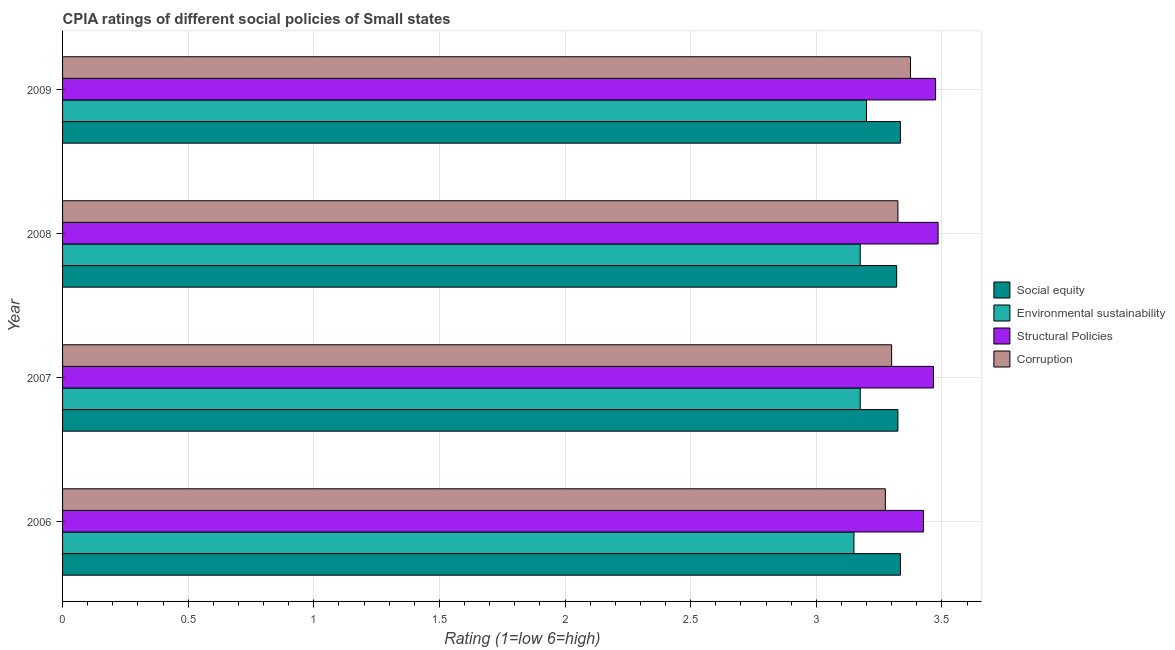How many different coloured bars are there?
Your answer should be compact. 4. How many groups of bars are there?
Offer a very short reply. 4. Are the number of bars on each tick of the Y-axis equal?
Your answer should be compact. Yes. What is the cpia rating of social equity in 2008?
Your response must be concise. 3.32. Across all years, what is the maximum cpia rating of social equity?
Offer a very short reply. 3.33. Across all years, what is the minimum cpia rating of environmental sustainability?
Provide a short and direct response. 3.15. What is the total cpia rating of structural policies in the graph?
Provide a short and direct response. 13.85. What is the difference between the cpia rating of structural policies in 2007 and that in 2008?
Ensure brevity in your answer.  -0.02. What is the difference between the cpia rating of social equity in 2007 and the cpia rating of corruption in 2008?
Your answer should be compact. 0. What is the average cpia rating of corruption per year?
Provide a short and direct response. 3.32. In the year 2006, what is the difference between the cpia rating of corruption and cpia rating of social equity?
Your answer should be very brief. -0.06. Is the cpia rating of environmental sustainability in 2007 less than that in 2008?
Make the answer very short. No. Is the difference between the cpia rating of structural policies in 2007 and 2009 greater than the difference between the cpia rating of corruption in 2007 and 2009?
Offer a terse response. Yes. What is the difference between the highest and the second highest cpia rating of environmental sustainability?
Keep it short and to the point. 0.03. In how many years, is the cpia rating of environmental sustainability greater than the average cpia rating of environmental sustainability taken over all years?
Your response must be concise. 1. Is the sum of the cpia rating of structural policies in 2006 and 2008 greater than the maximum cpia rating of corruption across all years?
Your answer should be compact. Yes. What does the 3rd bar from the top in 2006 represents?
Give a very brief answer. Environmental sustainability. What does the 1st bar from the bottom in 2009 represents?
Give a very brief answer. Social equity. Is it the case that in every year, the sum of the cpia rating of social equity and cpia rating of environmental sustainability is greater than the cpia rating of structural policies?
Your response must be concise. Yes. How many bars are there?
Make the answer very short. 16. What is the difference between two consecutive major ticks on the X-axis?
Provide a short and direct response. 0.5. Are the values on the major ticks of X-axis written in scientific E-notation?
Make the answer very short. No. Does the graph contain grids?
Offer a very short reply. Yes. How many legend labels are there?
Give a very brief answer. 4. How are the legend labels stacked?
Offer a very short reply. Vertical. What is the title of the graph?
Offer a terse response. CPIA ratings of different social policies of Small states. Does "Iceland" appear as one of the legend labels in the graph?
Your answer should be very brief. No. What is the label or title of the X-axis?
Give a very brief answer. Rating (1=low 6=high). What is the Rating (1=low 6=high) in Social equity in 2006?
Make the answer very short. 3.33. What is the Rating (1=low 6=high) in Environmental sustainability in 2006?
Offer a very short reply. 3.15. What is the Rating (1=low 6=high) in Structural Policies in 2006?
Provide a short and direct response. 3.43. What is the Rating (1=low 6=high) of Corruption in 2006?
Your answer should be compact. 3.27. What is the Rating (1=low 6=high) of Social equity in 2007?
Your answer should be very brief. 3.33. What is the Rating (1=low 6=high) in Environmental sustainability in 2007?
Make the answer very short. 3.17. What is the Rating (1=low 6=high) of Structural Policies in 2007?
Your answer should be compact. 3.47. What is the Rating (1=low 6=high) in Corruption in 2007?
Provide a succinct answer. 3.3. What is the Rating (1=low 6=high) of Social equity in 2008?
Your answer should be compact. 3.32. What is the Rating (1=low 6=high) of Environmental sustainability in 2008?
Your answer should be compact. 3.17. What is the Rating (1=low 6=high) of Structural Policies in 2008?
Your answer should be compact. 3.48. What is the Rating (1=low 6=high) in Corruption in 2008?
Your response must be concise. 3.33. What is the Rating (1=low 6=high) of Social equity in 2009?
Ensure brevity in your answer.  3.33. What is the Rating (1=low 6=high) in Environmental sustainability in 2009?
Ensure brevity in your answer.  3.2. What is the Rating (1=low 6=high) in Structural Policies in 2009?
Provide a succinct answer. 3.48. What is the Rating (1=low 6=high) of Corruption in 2009?
Keep it short and to the point. 3.38. Across all years, what is the maximum Rating (1=low 6=high) in Social equity?
Provide a succinct answer. 3.33. Across all years, what is the maximum Rating (1=low 6=high) in Structural Policies?
Your answer should be very brief. 3.48. Across all years, what is the maximum Rating (1=low 6=high) of Corruption?
Give a very brief answer. 3.38. Across all years, what is the minimum Rating (1=low 6=high) in Social equity?
Your answer should be very brief. 3.32. Across all years, what is the minimum Rating (1=low 6=high) in Environmental sustainability?
Offer a terse response. 3.15. Across all years, what is the minimum Rating (1=low 6=high) of Structural Policies?
Give a very brief answer. 3.43. Across all years, what is the minimum Rating (1=low 6=high) of Corruption?
Keep it short and to the point. 3.27. What is the total Rating (1=low 6=high) in Social equity in the graph?
Offer a very short reply. 13.31. What is the total Rating (1=low 6=high) in Structural Policies in the graph?
Your response must be concise. 13.85. What is the total Rating (1=low 6=high) of Corruption in the graph?
Offer a very short reply. 13.28. What is the difference between the Rating (1=low 6=high) in Social equity in 2006 and that in 2007?
Provide a short and direct response. 0.01. What is the difference between the Rating (1=low 6=high) in Environmental sustainability in 2006 and that in 2007?
Your response must be concise. -0.03. What is the difference between the Rating (1=low 6=high) of Structural Policies in 2006 and that in 2007?
Your response must be concise. -0.04. What is the difference between the Rating (1=low 6=high) of Corruption in 2006 and that in 2007?
Offer a very short reply. -0.03. What is the difference between the Rating (1=low 6=high) in Social equity in 2006 and that in 2008?
Your response must be concise. 0.01. What is the difference between the Rating (1=low 6=high) in Environmental sustainability in 2006 and that in 2008?
Make the answer very short. -0.03. What is the difference between the Rating (1=low 6=high) in Structural Policies in 2006 and that in 2008?
Provide a short and direct response. -0.06. What is the difference between the Rating (1=low 6=high) in Corruption in 2006 and that in 2008?
Ensure brevity in your answer.  -0.05. What is the difference between the Rating (1=low 6=high) in Environmental sustainability in 2006 and that in 2009?
Ensure brevity in your answer.  -0.05. What is the difference between the Rating (1=low 6=high) in Structural Policies in 2006 and that in 2009?
Your answer should be compact. -0.05. What is the difference between the Rating (1=low 6=high) of Corruption in 2006 and that in 2009?
Your response must be concise. -0.1. What is the difference between the Rating (1=low 6=high) in Social equity in 2007 and that in 2008?
Offer a terse response. 0.01. What is the difference between the Rating (1=low 6=high) in Environmental sustainability in 2007 and that in 2008?
Make the answer very short. 0. What is the difference between the Rating (1=low 6=high) in Structural Policies in 2007 and that in 2008?
Provide a succinct answer. -0.02. What is the difference between the Rating (1=low 6=high) of Corruption in 2007 and that in 2008?
Provide a short and direct response. -0.03. What is the difference between the Rating (1=low 6=high) in Social equity in 2007 and that in 2009?
Make the answer very short. -0.01. What is the difference between the Rating (1=low 6=high) of Environmental sustainability in 2007 and that in 2009?
Offer a very short reply. -0.03. What is the difference between the Rating (1=low 6=high) in Structural Policies in 2007 and that in 2009?
Your response must be concise. -0.01. What is the difference between the Rating (1=low 6=high) in Corruption in 2007 and that in 2009?
Make the answer very short. -0.07. What is the difference between the Rating (1=low 6=high) in Social equity in 2008 and that in 2009?
Give a very brief answer. -0.01. What is the difference between the Rating (1=low 6=high) of Environmental sustainability in 2008 and that in 2009?
Your answer should be compact. -0.03. What is the difference between the Rating (1=low 6=high) of Structural Policies in 2008 and that in 2009?
Ensure brevity in your answer.  0.01. What is the difference between the Rating (1=low 6=high) of Corruption in 2008 and that in 2009?
Your answer should be compact. -0.05. What is the difference between the Rating (1=low 6=high) of Social equity in 2006 and the Rating (1=low 6=high) of Environmental sustainability in 2007?
Provide a succinct answer. 0.16. What is the difference between the Rating (1=low 6=high) in Social equity in 2006 and the Rating (1=low 6=high) in Structural Policies in 2007?
Your answer should be very brief. -0.13. What is the difference between the Rating (1=low 6=high) of Social equity in 2006 and the Rating (1=low 6=high) of Corruption in 2007?
Make the answer very short. 0.04. What is the difference between the Rating (1=low 6=high) in Environmental sustainability in 2006 and the Rating (1=low 6=high) in Structural Policies in 2007?
Offer a terse response. -0.32. What is the difference between the Rating (1=low 6=high) of Structural Policies in 2006 and the Rating (1=low 6=high) of Corruption in 2007?
Provide a short and direct response. 0.13. What is the difference between the Rating (1=low 6=high) in Social equity in 2006 and the Rating (1=low 6=high) in Environmental sustainability in 2008?
Give a very brief answer. 0.16. What is the difference between the Rating (1=low 6=high) in Environmental sustainability in 2006 and the Rating (1=low 6=high) in Structural Policies in 2008?
Your response must be concise. -0.34. What is the difference between the Rating (1=low 6=high) of Environmental sustainability in 2006 and the Rating (1=low 6=high) of Corruption in 2008?
Your answer should be very brief. -0.17. What is the difference between the Rating (1=low 6=high) of Structural Policies in 2006 and the Rating (1=low 6=high) of Corruption in 2008?
Your response must be concise. 0.1. What is the difference between the Rating (1=low 6=high) of Social equity in 2006 and the Rating (1=low 6=high) of Environmental sustainability in 2009?
Your response must be concise. 0.14. What is the difference between the Rating (1=low 6=high) in Social equity in 2006 and the Rating (1=low 6=high) in Structural Policies in 2009?
Make the answer very short. -0.14. What is the difference between the Rating (1=low 6=high) in Social equity in 2006 and the Rating (1=low 6=high) in Corruption in 2009?
Your answer should be very brief. -0.04. What is the difference between the Rating (1=low 6=high) in Environmental sustainability in 2006 and the Rating (1=low 6=high) in Structural Policies in 2009?
Make the answer very short. -0.33. What is the difference between the Rating (1=low 6=high) of Environmental sustainability in 2006 and the Rating (1=low 6=high) of Corruption in 2009?
Your answer should be compact. -0.23. What is the difference between the Rating (1=low 6=high) in Structural Policies in 2006 and the Rating (1=low 6=high) in Corruption in 2009?
Your answer should be compact. 0.05. What is the difference between the Rating (1=low 6=high) in Social equity in 2007 and the Rating (1=low 6=high) in Environmental sustainability in 2008?
Offer a very short reply. 0.15. What is the difference between the Rating (1=low 6=high) in Social equity in 2007 and the Rating (1=low 6=high) in Structural Policies in 2008?
Your response must be concise. -0.16. What is the difference between the Rating (1=low 6=high) in Social equity in 2007 and the Rating (1=low 6=high) in Corruption in 2008?
Your answer should be very brief. 0. What is the difference between the Rating (1=low 6=high) in Environmental sustainability in 2007 and the Rating (1=low 6=high) in Structural Policies in 2008?
Ensure brevity in your answer.  -0.31. What is the difference between the Rating (1=low 6=high) in Structural Policies in 2007 and the Rating (1=low 6=high) in Corruption in 2008?
Offer a terse response. 0.14. What is the difference between the Rating (1=low 6=high) of Social equity in 2007 and the Rating (1=low 6=high) of Environmental sustainability in 2009?
Your answer should be very brief. 0.12. What is the difference between the Rating (1=low 6=high) of Social equity in 2007 and the Rating (1=low 6=high) of Structural Policies in 2009?
Provide a short and direct response. -0.15. What is the difference between the Rating (1=low 6=high) of Environmental sustainability in 2007 and the Rating (1=low 6=high) of Structural Policies in 2009?
Your response must be concise. -0.3. What is the difference between the Rating (1=low 6=high) of Structural Policies in 2007 and the Rating (1=low 6=high) of Corruption in 2009?
Give a very brief answer. 0.09. What is the difference between the Rating (1=low 6=high) of Social equity in 2008 and the Rating (1=low 6=high) of Environmental sustainability in 2009?
Your answer should be very brief. 0.12. What is the difference between the Rating (1=low 6=high) of Social equity in 2008 and the Rating (1=low 6=high) of Structural Policies in 2009?
Offer a terse response. -0.15. What is the difference between the Rating (1=low 6=high) in Social equity in 2008 and the Rating (1=low 6=high) in Corruption in 2009?
Offer a terse response. -0.06. What is the difference between the Rating (1=low 6=high) of Environmental sustainability in 2008 and the Rating (1=low 6=high) of Structural Policies in 2009?
Provide a short and direct response. -0.3. What is the difference between the Rating (1=low 6=high) in Environmental sustainability in 2008 and the Rating (1=low 6=high) in Corruption in 2009?
Keep it short and to the point. -0.2. What is the difference between the Rating (1=low 6=high) of Structural Policies in 2008 and the Rating (1=low 6=high) of Corruption in 2009?
Your answer should be very brief. 0.11. What is the average Rating (1=low 6=high) in Social equity per year?
Give a very brief answer. 3.33. What is the average Rating (1=low 6=high) in Environmental sustainability per year?
Offer a terse response. 3.17. What is the average Rating (1=low 6=high) in Structural Policies per year?
Make the answer very short. 3.46. What is the average Rating (1=low 6=high) of Corruption per year?
Provide a succinct answer. 3.32. In the year 2006, what is the difference between the Rating (1=low 6=high) of Social equity and Rating (1=low 6=high) of Environmental sustainability?
Ensure brevity in your answer.  0.18. In the year 2006, what is the difference between the Rating (1=low 6=high) in Social equity and Rating (1=low 6=high) in Structural Policies?
Your response must be concise. -0.09. In the year 2006, what is the difference between the Rating (1=low 6=high) of Environmental sustainability and Rating (1=low 6=high) of Structural Policies?
Your response must be concise. -0.28. In the year 2006, what is the difference between the Rating (1=low 6=high) of Environmental sustainability and Rating (1=low 6=high) of Corruption?
Your answer should be very brief. -0.12. In the year 2006, what is the difference between the Rating (1=low 6=high) of Structural Policies and Rating (1=low 6=high) of Corruption?
Your answer should be compact. 0.15. In the year 2007, what is the difference between the Rating (1=low 6=high) of Social equity and Rating (1=low 6=high) of Environmental sustainability?
Your response must be concise. 0.15. In the year 2007, what is the difference between the Rating (1=low 6=high) in Social equity and Rating (1=low 6=high) in Structural Policies?
Provide a succinct answer. -0.14. In the year 2007, what is the difference between the Rating (1=low 6=high) in Social equity and Rating (1=low 6=high) in Corruption?
Provide a succinct answer. 0.03. In the year 2007, what is the difference between the Rating (1=low 6=high) of Environmental sustainability and Rating (1=low 6=high) of Structural Policies?
Your response must be concise. -0.29. In the year 2007, what is the difference between the Rating (1=low 6=high) in Environmental sustainability and Rating (1=low 6=high) in Corruption?
Keep it short and to the point. -0.12. In the year 2007, what is the difference between the Rating (1=low 6=high) in Structural Policies and Rating (1=low 6=high) in Corruption?
Offer a terse response. 0.17. In the year 2008, what is the difference between the Rating (1=low 6=high) in Social equity and Rating (1=low 6=high) in Environmental sustainability?
Provide a short and direct response. 0.14. In the year 2008, what is the difference between the Rating (1=low 6=high) of Social equity and Rating (1=low 6=high) of Structural Policies?
Make the answer very short. -0.17. In the year 2008, what is the difference between the Rating (1=low 6=high) of Social equity and Rating (1=low 6=high) of Corruption?
Your answer should be compact. -0.01. In the year 2008, what is the difference between the Rating (1=low 6=high) of Environmental sustainability and Rating (1=low 6=high) of Structural Policies?
Provide a succinct answer. -0.31. In the year 2008, what is the difference between the Rating (1=low 6=high) in Structural Policies and Rating (1=low 6=high) in Corruption?
Give a very brief answer. 0.16. In the year 2009, what is the difference between the Rating (1=low 6=high) in Social equity and Rating (1=low 6=high) in Environmental sustainability?
Ensure brevity in your answer.  0.14. In the year 2009, what is the difference between the Rating (1=low 6=high) in Social equity and Rating (1=low 6=high) in Structural Policies?
Offer a very short reply. -0.14. In the year 2009, what is the difference between the Rating (1=low 6=high) of Social equity and Rating (1=low 6=high) of Corruption?
Ensure brevity in your answer.  -0.04. In the year 2009, what is the difference between the Rating (1=low 6=high) of Environmental sustainability and Rating (1=low 6=high) of Structural Policies?
Provide a succinct answer. -0.28. In the year 2009, what is the difference between the Rating (1=low 6=high) of Environmental sustainability and Rating (1=low 6=high) of Corruption?
Your response must be concise. -0.17. In the year 2009, what is the difference between the Rating (1=low 6=high) in Structural Policies and Rating (1=low 6=high) in Corruption?
Give a very brief answer. 0.1. What is the ratio of the Rating (1=low 6=high) in Environmental sustainability in 2006 to that in 2007?
Offer a terse response. 0.99. What is the ratio of the Rating (1=low 6=high) in Structural Policies in 2006 to that in 2007?
Provide a short and direct response. 0.99. What is the ratio of the Rating (1=low 6=high) of Corruption in 2006 to that in 2007?
Provide a succinct answer. 0.99. What is the ratio of the Rating (1=low 6=high) in Structural Policies in 2006 to that in 2008?
Keep it short and to the point. 0.98. What is the ratio of the Rating (1=low 6=high) in Corruption in 2006 to that in 2008?
Your answer should be compact. 0.98. What is the ratio of the Rating (1=low 6=high) in Environmental sustainability in 2006 to that in 2009?
Offer a very short reply. 0.98. What is the ratio of the Rating (1=low 6=high) in Structural Policies in 2006 to that in 2009?
Give a very brief answer. 0.99. What is the ratio of the Rating (1=low 6=high) of Corruption in 2006 to that in 2009?
Offer a terse response. 0.97. What is the ratio of the Rating (1=low 6=high) of Social equity in 2007 to that in 2008?
Keep it short and to the point. 1. What is the ratio of the Rating (1=low 6=high) of Environmental sustainability in 2007 to that in 2008?
Your answer should be compact. 1. What is the ratio of the Rating (1=low 6=high) in Structural Policies in 2007 to that in 2008?
Give a very brief answer. 0.99. What is the ratio of the Rating (1=low 6=high) in Social equity in 2007 to that in 2009?
Your answer should be compact. 1. What is the ratio of the Rating (1=low 6=high) of Corruption in 2007 to that in 2009?
Your response must be concise. 0.98. What is the ratio of the Rating (1=low 6=high) of Corruption in 2008 to that in 2009?
Provide a short and direct response. 0.99. What is the difference between the highest and the second highest Rating (1=low 6=high) of Environmental sustainability?
Make the answer very short. 0.03. What is the difference between the highest and the second highest Rating (1=low 6=high) in Structural Policies?
Provide a succinct answer. 0.01. What is the difference between the highest and the lowest Rating (1=low 6=high) of Social equity?
Keep it short and to the point. 0.01. What is the difference between the highest and the lowest Rating (1=low 6=high) in Structural Policies?
Your answer should be compact. 0.06. 